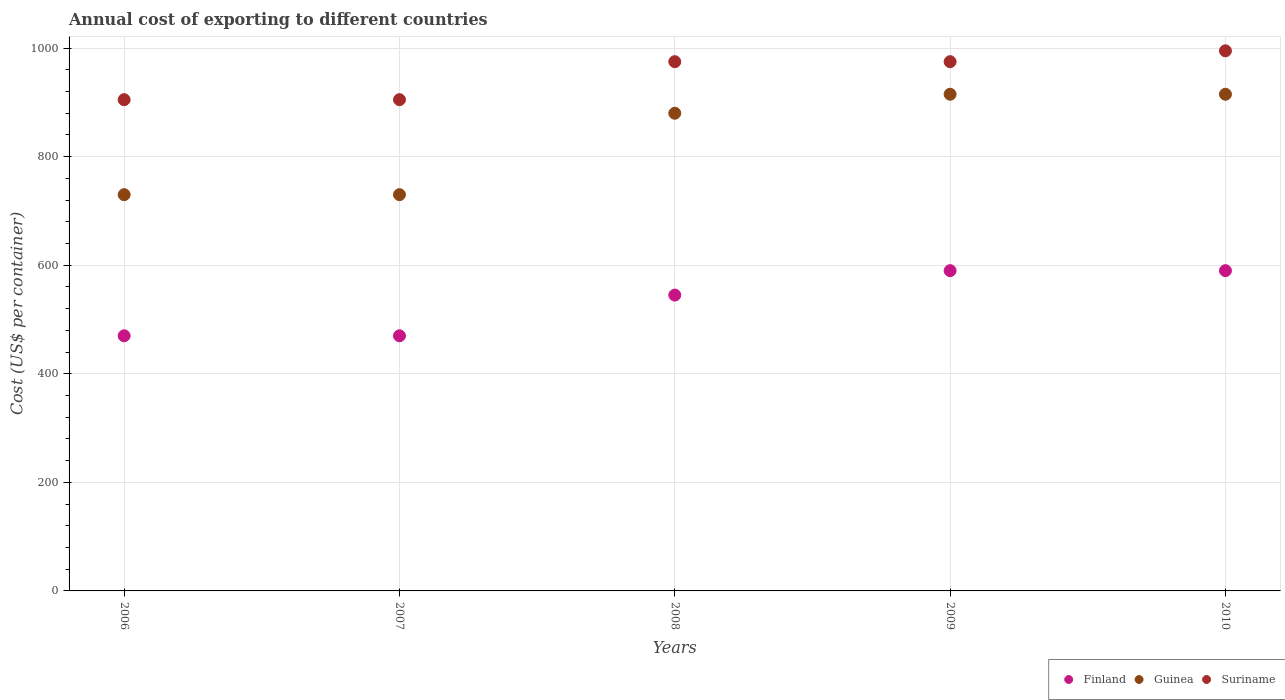How many different coloured dotlines are there?
Ensure brevity in your answer.  3. What is the total annual cost of exporting in Guinea in 2007?
Offer a very short reply. 730. Across all years, what is the maximum total annual cost of exporting in Suriname?
Offer a terse response. 995. Across all years, what is the minimum total annual cost of exporting in Guinea?
Give a very brief answer. 730. In which year was the total annual cost of exporting in Guinea maximum?
Offer a terse response. 2009. What is the total total annual cost of exporting in Finland in the graph?
Provide a succinct answer. 2665. What is the difference between the total annual cost of exporting in Finland in 2007 and that in 2010?
Offer a terse response. -120. What is the difference between the total annual cost of exporting in Suriname in 2009 and the total annual cost of exporting in Finland in 2010?
Provide a short and direct response. 385. What is the average total annual cost of exporting in Suriname per year?
Your answer should be compact. 951. In the year 2006, what is the difference between the total annual cost of exporting in Finland and total annual cost of exporting in Suriname?
Ensure brevity in your answer.  -435. In how many years, is the total annual cost of exporting in Finland greater than 240 US$?
Offer a very short reply. 5. What is the ratio of the total annual cost of exporting in Finland in 2006 to that in 2007?
Give a very brief answer. 1. Is the difference between the total annual cost of exporting in Finland in 2006 and 2010 greater than the difference between the total annual cost of exporting in Suriname in 2006 and 2010?
Your answer should be compact. No. What is the difference between the highest and the lowest total annual cost of exporting in Finland?
Your response must be concise. 120. In how many years, is the total annual cost of exporting in Finland greater than the average total annual cost of exporting in Finland taken over all years?
Keep it short and to the point. 3. Does the total annual cost of exporting in Suriname monotonically increase over the years?
Make the answer very short. No. How many dotlines are there?
Offer a terse response. 3. How many years are there in the graph?
Provide a short and direct response. 5. What is the difference between two consecutive major ticks on the Y-axis?
Ensure brevity in your answer.  200. Are the values on the major ticks of Y-axis written in scientific E-notation?
Your response must be concise. No. How are the legend labels stacked?
Provide a succinct answer. Horizontal. What is the title of the graph?
Offer a terse response. Annual cost of exporting to different countries. Does "Puerto Rico" appear as one of the legend labels in the graph?
Make the answer very short. No. What is the label or title of the Y-axis?
Make the answer very short. Cost (US$ per container). What is the Cost (US$ per container) of Finland in 2006?
Offer a very short reply. 470. What is the Cost (US$ per container) in Guinea in 2006?
Offer a terse response. 730. What is the Cost (US$ per container) in Suriname in 2006?
Your answer should be compact. 905. What is the Cost (US$ per container) of Finland in 2007?
Offer a terse response. 470. What is the Cost (US$ per container) in Guinea in 2007?
Your response must be concise. 730. What is the Cost (US$ per container) in Suriname in 2007?
Provide a succinct answer. 905. What is the Cost (US$ per container) of Finland in 2008?
Keep it short and to the point. 545. What is the Cost (US$ per container) in Guinea in 2008?
Keep it short and to the point. 880. What is the Cost (US$ per container) in Suriname in 2008?
Make the answer very short. 975. What is the Cost (US$ per container) in Finland in 2009?
Give a very brief answer. 590. What is the Cost (US$ per container) in Guinea in 2009?
Your response must be concise. 915. What is the Cost (US$ per container) in Suriname in 2009?
Give a very brief answer. 975. What is the Cost (US$ per container) of Finland in 2010?
Provide a succinct answer. 590. What is the Cost (US$ per container) in Guinea in 2010?
Make the answer very short. 915. What is the Cost (US$ per container) in Suriname in 2010?
Your answer should be compact. 995. Across all years, what is the maximum Cost (US$ per container) in Finland?
Give a very brief answer. 590. Across all years, what is the maximum Cost (US$ per container) in Guinea?
Keep it short and to the point. 915. Across all years, what is the maximum Cost (US$ per container) of Suriname?
Your response must be concise. 995. Across all years, what is the minimum Cost (US$ per container) of Finland?
Ensure brevity in your answer.  470. Across all years, what is the minimum Cost (US$ per container) in Guinea?
Keep it short and to the point. 730. Across all years, what is the minimum Cost (US$ per container) in Suriname?
Provide a succinct answer. 905. What is the total Cost (US$ per container) in Finland in the graph?
Provide a succinct answer. 2665. What is the total Cost (US$ per container) of Guinea in the graph?
Provide a succinct answer. 4170. What is the total Cost (US$ per container) in Suriname in the graph?
Your answer should be compact. 4755. What is the difference between the Cost (US$ per container) of Finland in 2006 and that in 2007?
Give a very brief answer. 0. What is the difference between the Cost (US$ per container) in Guinea in 2006 and that in 2007?
Your answer should be very brief. 0. What is the difference between the Cost (US$ per container) of Finland in 2006 and that in 2008?
Offer a terse response. -75. What is the difference between the Cost (US$ per container) of Guinea in 2006 and that in 2008?
Make the answer very short. -150. What is the difference between the Cost (US$ per container) in Suriname in 2006 and that in 2008?
Your answer should be compact. -70. What is the difference between the Cost (US$ per container) of Finland in 2006 and that in 2009?
Your response must be concise. -120. What is the difference between the Cost (US$ per container) in Guinea in 2006 and that in 2009?
Ensure brevity in your answer.  -185. What is the difference between the Cost (US$ per container) in Suriname in 2006 and that in 2009?
Your response must be concise. -70. What is the difference between the Cost (US$ per container) in Finland in 2006 and that in 2010?
Keep it short and to the point. -120. What is the difference between the Cost (US$ per container) in Guinea in 2006 and that in 2010?
Make the answer very short. -185. What is the difference between the Cost (US$ per container) in Suriname in 2006 and that in 2010?
Provide a short and direct response. -90. What is the difference between the Cost (US$ per container) in Finland in 2007 and that in 2008?
Keep it short and to the point. -75. What is the difference between the Cost (US$ per container) of Guinea in 2007 and that in 2008?
Keep it short and to the point. -150. What is the difference between the Cost (US$ per container) in Suriname in 2007 and that in 2008?
Your answer should be compact. -70. What is the difference between the Cost (US$ per container) in Finland in 2007 and that in 2009?
Provide a succinct answer. -120. What is the difference between the Cost (US$ per container) in Guinea in 2007 and that in 2009?
Your answer should be very brief. -185. What is the difference between the Cost (US$ per container) of Suriname in 2007 and that in 2009?
Your answer should be compact. -70. What is the difference between the Cost (US$ per container) in Finland in 2007 and that in 2010?
Keep it short and to the point. -120. What is the difference between the Cost (US$ per container) of Guinea in 2007 and that in 2010?
Make the answer very short. -185. What is the difference between the Cost (US$ per container) in Suriname in 2007 and that in 2010?
Provide a succinct answer. -90. What is the difference between the Cost (US$ per container) in Finland in 2008 and that in 2009?
Give a very brief answer. -45. What is the difference between the Cost (US$ per container) of Guinea in 2008 and that in 2009?
Give a very brief answer. -35. What is the difference between the Cost (US$ per container) in Suriname in 2008 and that in 2009?
Offer a terse response. 0. What is the difference between the Cost (US$ per container) of Finland in 2008 and that in 2010?
Your answer should be very brief. -45. What is the difference between the Cost (US$ per container) of Guinea in 2008 and that in 2010?
Keep it short and to the point. -35. What is the difference between the Cost (US$ per container) of Finland in 2009 and that in 2010?
Your answer should be very brief. 0. What is the difference between the Cost (US$ per container) in Suriname in 2009 and that in 2010?
Your response must be concise. -20. What is the difference between the Cost (US$ per container) of Finland in 2006 and the Cost (US$ per container) of Guinea in 2007?
Your answer should be very brief. -260. What is the difference between the Cost (US$ per container) in Finland in 2006 and the Cost (US$ per container) in Suriname in 2007?
Keep it short and to the point. -435. What is the difference between the Cost (US$ per container) in Guinea in 2006 and the Cost (US$ per container) in Suriname in 2007?
Ensure brevity in your answer.  -175. What is the difference between the Cost (US$ per container) in Finland in 2006 and the Cost (US$ per container) in Guinea in 2008?
Ensure brevity in your answer.  -410. What is the difference between the Cost (US$ per container) of Finland in 2006 and the Cost (US$ per container) of Suriname in 2008?
Keep it short and to the point. -505. What is the difference between the Cost (US$ per container) of Guinea in 2006 and the Cost (US$ per container) of Suriname in 2008?
Ensure brevity in your answer.  -245. What is the difference between the Cost (US$ per container) of Finland in 2006 and the Cost (US$ per container) of Guinea in 2009?
Offer a very short reply. -445. What is the difference between the Cost (US$ per container) in Finland in 2006 and the Cost (US$ per container) in Suriname in 2009?
Make the answer very short. -505. What is the difference between the Cost (US$ per container) of Guinea in 2006 and the Cost (US$ per container) of Suriname in 2009?
Offer a terse response. -245. What is the difference between the Cost (US$ per container) in Finland in 2006 and the Cost (US$ per container) in Guinea in 2010?
Give a very brief answer. -445. What is the difference between the Cost (US$ per container) in Finland in 2006 and the Cost (US$ per container) in Suriname in 2010?
Ensure brevity in your answer.  -525. What is the difference between the Cost (US$ per container) in Guinea in 2006 and the Cost (US$ per container) in Suriname in 2010?
Your answer should be very brief. -265. What is the difference between the Cost (US$ per container) of Finland in 2007 and the Cost (US$ per container) of Guinea in 2008?
Your answer should be compact. -410. What is the difference between the Cost (US$ per container) of Finland in 2007 and the Cost (US$ per container) of Suriname in 2008?
Give a very brief answer. -505. What is the difference between the Cost (US$ per container) in Guinea in 2007 and the Cost (US$ per container) in Suriname in 2008?
Offer a very short reply. -245. What is the difference between the Cost (US$ per container) of Finland in 2007 and the Cost (US$ per container) of Guinea in 2009?
Keep it short and to the point. -445. What is the difference between the Cost (US$ per container) of Finland in 2007 and the Cost (US$ per container) of Suriname in 2009?
Give a very brief answer. -505. What is the difference between the Cost (US$ per container) of Guinea in 2007 and the Cost (US$ per container) of Suriname in 2009?
Provide a short and direct response. -245. What is the difference between the Cost (US$ per container) of Finland in 2007 and the Cost (US$ per container) of Guinea in 2010?
Your answer should be very brief. -445. What is the difference between the Cost (US$ per container) in Finland in 2007 and the Cost (US$ per container) in Suriname in 2010?
Your answer should be very brief. -525. What is the difference between the Cost (US$ per container) in Guinea in 2007 and the Cost (US$ per container) in Suriname in 2010?
Keep it short and to the point. -265. What is the difference between the Cost (US$ per container) of Finland in 2008 and the Cost (US$ per container) of Guinea in 2009?
Offer a terse response. -370. What is the difference between the Cost (US$ per container) in Finland in 2008 and the Cost (US$ per container) in Suriname in 2009?
Your answer should be compact. -430. What is the difference between the Cost (US$ per container) of Guinea in 2008 and the Cost (US$ per container) of Suriname in 2009?
Your answer should be very brief. -95. What is the difference between the Cost (US$ per container) in Finland in 2008 and the Cost (US$ per container) in Guinea in 2010?
Offer a terse response. -370. What is the difference between the Cost (US$ per container) of Finland in 2008 and the Cost (US$ per container) of Suriname in 2010?
Offer a terse response. -450. What is the difference between the Cost (US$ per container) in Guinea in 2008 and the Cost (US$ per container) in Suriname in 2010?
Your response must be concise. -115. What is the difference between the Cost (US$ per container) in Finland in 2009 and the Cost (US$ per container) in Guinea in 2010?
Give a very brief answer. -325. What is the difference between the Cost (US$ per container) in Finland in 2009 and the Cost (US$ per container) in Suriname in 2010?
Offer a very short reply. -405. What is the difference between the Cost (US$ per container) of Guinea in 2009 and the Cost (US$ per container) of Suriname in 2010?
Keep it short and to the point. -80. What is the average Cost (US$ per container) of Finland per year?
Offer a terse response. 533. What is the average Cost (US$ per container) of Guinea per year?
Offer a terse response. 834. What is the average Cost (US$ per container) in Suriname per year?
Offer a very short reply. 951. In the year 2006, what is the difference between the Cost (US$ per container) of Finland and Cost (US$ per container) of Guinea?
Offer a very short reply. -260. In the year 2006, what is the difference between the Cost (US$ per container) of Finland and Cost (US$ per container) of Suriname?
Offer a very short reply. -435. In the year 2006, what is the difference between the Cost (US$ per container) of Guinea and Cost (US$ per container) of Suriname?
Your answer should be very brief. -175. In the year 2007, what is the difference between the Cost (US$ per container) of Finland and Cost (US$ per container) of Guinea?
Provide a succinct answer. -260. In the year 2007, what is the difference between the Cost (US$ per container) of Finland and Cost (US$ per container) of Suriname?
Your response must be concise. -435. In the year 2007, what is the difference between the Cost (US$ per container) of Guinea and Cost (US$ per container) of Suriname?
Provide a short and direct response. -175. In the year 2008, what is the difference between the Cost (US$ per container) in Finland and Cost (US$ per container) in Guinea?
Make the answer very short. -335. In the year 2008, what is the difference between the Cost (US$ per container) of Finland and Cost (US$ per container) of Suriname?
Your answer should be compact. -430. In the year 2008, what is the difference between the Cost (US$ per container) of Guinea and Cost (US$ per container) of Suriname?
Offer a very short reply. -95. In the year 2009, what is the difference between the Cost (US$ per container) in Finland and Cost (US$ per container) in Guinea?
Provide a succinct answer. -325. In the year 2009, what is the difference between the Cost (US$ per container) of Finland and Cost (US$ per container) of Suriname?
Your answer should be compact. -385. In the year 2009, what is the difference between the Cost (US$ per container) in Guinea and Cost (US$ per container) in Suriname?
Provide a short and direct response. -60. In the year 2010, what is the difference between the Cost (US$ per container) in Finland and Cost (US$ per container) in Guinea?
Offer a very short reply. -325. In the year 2010, what is the difference between the Cost (US$ per container) in Finland and Cost (US$ per container) in Suriname?
Make the answer very short. -405. In the year 2010, what is the difference between the Cost (US$ per container) in Guinea and Cost (US$ per container) in Suriname?
Offer a very short reply. -80. What is the ratio of the Cost (US$ per container) of Finland in 2006 to that in 2007?
Ensure brevity in your answer.  1. What is the ratio of the Cost (US$ per container) of Guinea in 2006 to that in 2007?
Keep it short and to the point. 1. What is the ratio of the Cost (US$ per container) of Finland in 2006 to that in 2008?
Make the answer very short. 0.86. What is the ratio of the Cost (US$ per container) of Guinea in 2006 to that in 2008?
Offer a very short reply. 0.83. What is the ratio of the Cost (US$ per container) in Suriname in 2006 to that in 2008?
Your response must be concise. 0.93. What is the ratio of the Cost (US$ per container) in Finland in 2006 to that in 2009?
Keep it short and to the point. 0.8. What is the ratio of the Cost (US$ per container) of Guinea in 2006 to that in 2009?
Keep it short and to the point. 0.8. What is the ratio of the Cost (US$ per container) in Suriname in 2006 to that in 2009?
Give a very brief answer. 0.93. What is the ratio of the Cost (US$ per container) of Finland in 2006 to that in 2010?
Ensure brevity in your answer.  0.8. What is the ratio of the Cost (US$ per container) in Guinea in 2006 to that in 2010?
Provide a succinct answer. 0.8. What is the ratio of the Cost (US$ per container) in Suriname in 2006 to that in 2010?
Offer a terse response. 0.91. What is the ratio of the Cost (US$ per container) in Finland in 2007 to that in 2008?
Your response must be concise. 0.86. What is the ratio of the Cost (US$ per container) in Guinea in 2007 to that in 2008?
Provide a short and direct response. 0.83. What is the ratio of the Cost (US$ per container) of Suriname in 2007 to that in 2008?
Make the answer very short. 0.93. What is the ratio of the Cost (US$ per container) in Finland in 2007 to that in 2009?
Provide a short and direct response. 0.8. What is the ratio of the Cost (US$ per container) of Guinea in 2007 to that in 2009?
Your response must be concise. 0.8. What is the ratio of the Cost (US$ per container) of Suriname in 2007 to that in 2009?
Give a very brief answer. 0.93. What is the ratio of the Cost (US$ per container) in Finland in 2007 to that in 2010?
Your answer should be very brief. 0.8. What is the ratio of the Cost (US$ per container) in Guinea in 2007 to that in 2010?
Give a very brief answer. 0.8. What is the ratio of the Cost (US$ per container) of Suriname in 2007 to that in 2010?
Give a very brief answer. 0.91. What is the ratio of the Cost (US$ per container) of Finland in 2008 to that in 2009?
Keep it short and to the point. 0.92. What is the ratio of the Cost (US$ per container) in Guinea in 2008 to that in 2009?
Ensure brevity in your answer.  0.96. What is the ratio of the Cost (US$ per container) in Finland in 2008 to that in 2010?
Provide a succinct answer. 0.92. What is the ratio of the Cost (US$ per container) in Guinea in 2008 to that in 2010?
Give a very brief answer. 0.96. What is the ratio of the Cost (US$ per container) of Suriname in 2008 to that in 2010?
Your answer should be very brief. 0.98. What is the ratio of the Cost (US$ per container) of Finland in 2009 to that in 2010?
Ensure brevity in your answer.  1. What is the ratio of the Cost (US$ per container) in Guinea in 2009 to that in 2010?
Your answer should be very brief. 1. What is the ratio of the Cost (US$ per container) of Suriname in 2009 to that in 2010?
Your response must be concise. 0.98. What is the difference between the highest and the second highest Cost (US$ per container) in Finland?
Make the answer very short. 0. What is the difference between the highest and the second highest Cost (US$ per container) of Suriname?
Keep it short and to the point. 20. What is the difference between the highest and the lowest Cost (US$ per container) of Finland?
Provide a succinct answer. 120. What is the difference between the highest and the lowest Cost (US$ per container) in Guinea?
Provide a succinct answer. 185. What is the difference between the highest and the lowest Cost (US$ per container) of Suriname?
Offer a terse response. 90. 